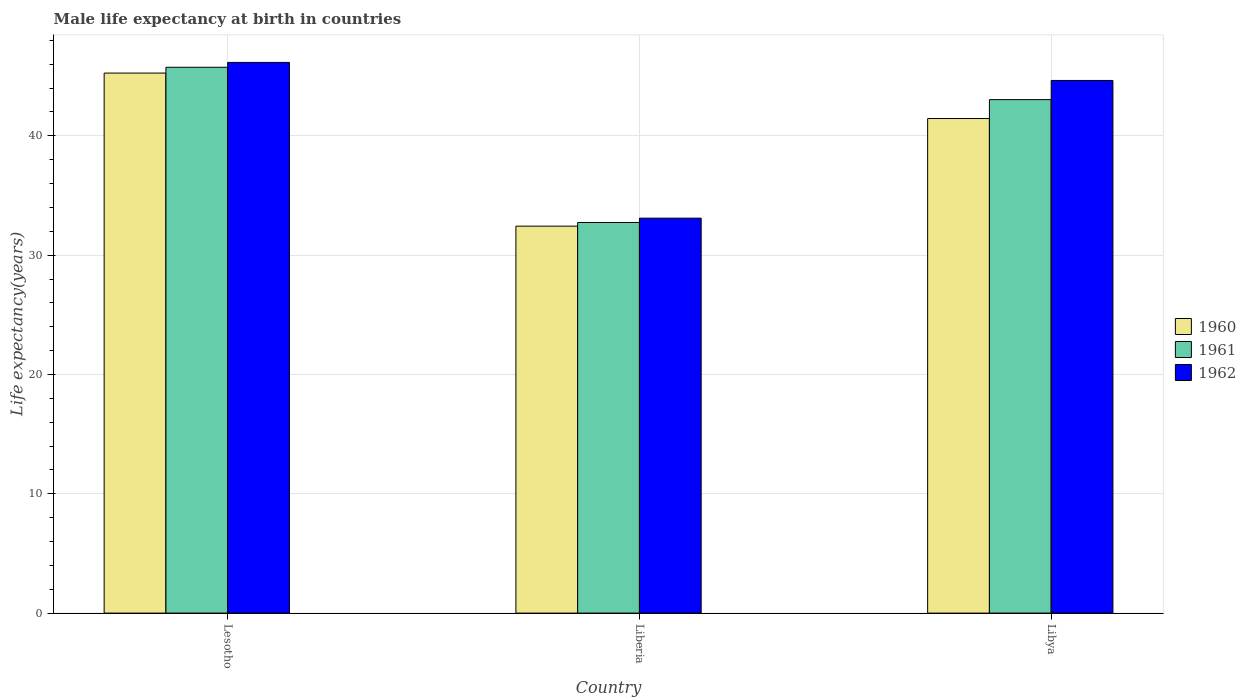How many groups of bars are there?
Your response must be concise. 3. Are the number of bars per tick equal to the number of legend labels?
Make the answer very short. Yes. How many bars are there on the 3rd tick from the left?
Your answer should be very brief. 3. How many bars are there on the 3rd tick from the right?
Your answer should be compact. 3. What is the label of the 3rd group of bars from the left?
Your response must be concise. Libya. In how many cases, is the number of bars for a given country not equal to the number of legend labels?
Make the answer very short. 0. What is the male life expectancy at birth in 1962 in Liberia?
Ensure brevity in your answer.  33.1. Across all countries, what is the maximum male life expectancy at birth in 1961?
Offer a very short reply. 45.74. Across all countries, what is the minimum male life expectancy at birth in 1962?
Your response must be concise. 33.1. In which country was the male life expectancy at birth in 1961 maximum?
Provide a short and direct response. Lesotho. In which country was the male life expectancy at birth in 1960 minimum?
Provide a succinct answer. Liberia. What is the total male life expectancy at birth in 1960 in the graph?
Make the answer very short. 119.14. What is the difference between the male life expectancy at birth in 1962 in Lesotho and that in Libya?
Offer a terse response. 1.51. What is the difference between the male life expectancy at birth in 1960 in Libya and the male life expectancy at birth in 1962 in Lesotho?
Your answer should be compact. -4.7. What is the average male life expectancy at birth in 1961 per country?
Make the answer very short. 40.5. What is the difference between the male life expectancy at birth of/in 1961 and male life expectancy at birth of/in 1960 in Lesotho?
Your answer should be compact. 0.49. In how many countries, is the male life expectancy at birth in 1960 greater than 34 years?
Give a very brief answer. 2. What is the ratio of the male life expectancy at birth in 1961 in Liberia to that in Libya?
Make the answer very short. 0.76. What is the difference between the highest and the second highest male life expectancy at birth in 1962?
Make the answer very short. -11.54. What is the difference between the highest and the lowest male life expectancy at birth in 1962?
Offer a terse response. 13.05. In how many countries, is the male life expectancy at birth in 1961 greater than the average male life expectancy at birth in 1961 taken over all countries?
Ensure brevity in your answer.  2. What does the 1st bar from the right in Lesotho represents?
Your response must be concise. 1962. Is it the case that in every country, the sum of the male life expectancy at birth in 1961 and male life expectancy at birth in 1960 is greater than the male life expectancy at birth in 1962?
Provide a short and direct response. Yes. Are all the bars in the graph horizontal?
Offer a very short reply. No. How many countries are there in the graph?
Make the answer very short. 3. Does the graph contain any zero values?
Your answer should be very brief. No. Where does the legend appear in the graph?
Make the answer very short. Center right. What is the title of the graph?
Give a very brief answer. Male life expectancy at birth in countries. What is the label or title of the X-axis?
Give a very brief answer. Country. What is the label or title of the Y-axis?
Give a very brief answer. Life expectancy(years). What is the Life expectancy(years) of 1960 in Lesotho?
Ensure brevity in your answer.  45.26. What is the Life expectancy(years) in 1961 in Lesotho?
Provide a short and direct response. 45.74. What is the Life expectancy(years) in 1962 in Lesotho?
Keep it short and to the point. 46.15. What is the Life expectancy(years) in 1960 in Liberia?
Provide a succinct answer. 32.43. What is the Life expectancy(years) in 1961 in Liberia?
Make the answer very short. 32.74. What is the Life expectancy(years) in 1962 in Liberia?
Your answer should be very brief. 33.1. What is the Life expectancy(years) of 1960 in Libya?
Ensure brevity in your answer.  41.45. What is the Life expectancy(years) in 1961 in Libya?
Offer a very short reply. 43.03. What is the Life expectancy(years) of 1962 in Libya?
Your response must be concise. 44.64. Across all countries, what is the maximum Life expectancy(years) in 1960?
Provide a succinct answer. 45.26. Across all countries, what is the maximum Life expectancy(years) of 1961?
Offer a terse response. 45.74. Across all countries, what is the maximum Life expectancy(years) of 1962?
Make the answer very short. 46.15. Across all countries, what is the minimum Life expectancy(years) in 1960?
Ensure brevity in your answer.  32.43. Across all countries, what is the minimum Life expectancy(years) of 1961?
Keep it short and to the point. 32.74. Across all countries, what is the minimum Life expectancy(years) in 1962?
Your answer should be compact. 33.1. What is the total Life expectancy(years) of 1960 in the graph?
Your answer should be very brief. 119.14. What is the total Life expectancy(years) of 1961 in the graph?
Your answer should be compact. 121.52. What is the total Life expectancy(years) in 1962 in the graph?
Make the answer very short. 123.89. What is the difference between the Life expectancy(years) of 1960 in Lesotho and that in Liberia?
Your answer should be compact. 12.83. What is the difference between the Life expectancy(years) of 1961 in Lesotho and that in Liberia?
Offer a terse response. 13.01. What is the difference between the Life expectancy(years) of 1962 in Lesotho and that in Liberia?
Offer a terse response. 13.05. What is the difference between the Life expectancy(years) in 1960 in Lesotho and that in Libya?
Your response must be concise. 3.81. What is the difference between the Life expectancy(years) of 1961 in Lesotho and that in Libya?
Your answer should be very brief. 2.71. What is the difference between the Life expectancy(years) of 1962 in Lesotho and that in Libya?
Ensure brevity in your answer.  1.51. What is the difference between the Life expectancy(years) of 1960 in Liberia and that in Libya?
Offer a very short reply. -9.02. What is the difference between the Life expectancy(years) in 1961 in Liberia and that in Libya?
Ensure brevity in your answer.  -10.3. What is the difference between the Life expectancy(years) of 1962 in Liberia and that in Libya?
Provide a succinct answer. -11.54. What is the difference between the Life expectancy(years) in 1960 in Lesotho and the Life expectancy(years) in 1961 in Liberia?
Give a very brief answer. 12.52. What is the difference between the Life expectancy(years) in 1960 in Lesotho and the Life expectancy(years) in 1962 in Liberia?
Your answer should be very brief. 12.16. What is the difference between the Life expectancy(years) of 1961 in Lesotho and the Life expectancy(years) of 1962 in Liberia?
Offer a very short reply. 12.64. What is the difference between the Life expectancy(years) in 1960 in Lesotho and the Life expectancy(years) in 1961 in Libya?
Your answer should be compact. 2.23. What is the difference between the Life expectancy(years) in 1960 in Lesotho and the Life expectancy(years) in 1962 in Libya?
Provide a succinct answer. 0.62. What is the difference between the Life expectancy(years) of 1961 in Lesotho and the Life expectancy(years) of 1962 in Libya?
Your answer should be compact. 1.1. What is the difference between the Life expectancy(years) in 1960 in Liberia and the Life expectancy(years) in 1961 in Libya?
Keep it short and to the point. -10.6. What is the difference between the Life expectancy(years) in 1960 in Liberia and the Life expectancy(years) in 1962 in Libya?
Ensure brevity in your answer.  -12.21. What is the difference between the Life expectancy(years) of 1961 in Liberia and the Life expectancy(years) of 1962 in Libya?
Your response must be concise. -11.9. What is the average Life expectancy(years) of 1960 per country?
Give a very brief answer. 39.71. What is the average Life expectancy(years) of 1961 per country?
Provide a short and direct response. 40.51. What is the average Life expectancy(years) of 1962 per country?
Make the answer very short. 41.3. What is the difference between the Life expectancy(years) of 1960 and Life expectancy(years) of 1961 in Lesotho?
Offer a very short reply. -0.48. What is the difference between the Life expectancy(years) in 1960 and Life expectancy(years) in 1962 in Lesotho?
Make the answer very short. -0.89. What is the difference between the Life expectancy(years) in 1961 and Life expectancy(years) in 1962 in Lesotho?
Provide a succinct answer. -0.41. What is the difference between the Life expectancy(years) in 1960 and Life expectancy(years) in 1961 in Liberia?
Your response must be concise. -0.31. What is the difference between the Life expectancy(years) of 1960 and Life expectancy(years) of 1962 in Liberia?
Provide a succinct answer. -0.67. What is the difference between the Life expectancy(years) of 1961 and Life expectancy(years) of 1962 in Liberia?
Your answer should be very brief. -0.36. What is the difference between the Life expectancy(years) in 1960 and Life expectancy(years) in 1961 in Libya?
Offer a terse response. -1.58. What is the difference between the Life expectancy(years) in 1960 and Life expectancy(years) in 1962 in Libya?
Your answer should be very brief. -3.19. What is the difference between the Life expectancy(years) in 1961 and Life expectancy(years) in 1962 in Libya?
Provide a succinct answer. -1.6. What is the ratio of the Life expectancy(years) in 1960 in Lesotho to that in Liberia?
Your response must be concise. 1.4. What is the ratio of the Life expectancy(years) of 1961 in Lesotho to that in Liberia?
Your answer should be very brief. 1.4. What is the ratio of the Life expectancy(years) of 1962 in Lesotho to that in Liberia?
Offer a very short reply. 1.39. What is the ratio of the Life expectancy(years) in 1960 in Lesotho to that in Libya?
Your answer should be very brief. 1.09. What is the ratio of the Life expectancy(years) of 1961 in Lesotho to that in Libya?
Give a very brief answer. 1.06. What is the ratio of the Life expectancy(years) of 1962 in Lesotho to that in Libya?
Ensure brevity in your answer.  1.03. What is the ratio of the Life expectancy(years) in 1960 in Liberia to that in Libya?
Provide a short and direct response. 0.78. What is the ratio of the Life expectancy(years) in 1961 in Liberia to that in Libya?
Give a very brief answer. 0.76. What is the ratio of the Life expectancy(years) of 1962 in Liberia to that in Libya?
Give a very brief answer. 0.74. What is the difference between the highest and the second highest Life expectancy(years) of 1960?
Provide a short and direct response. 3.81. What is the difference between the highest and the second highest Life expectancy(years) in 1961?
Offer a very short reply. 2.71. What is the difference between the highest and the second highest Life expectancy(years) in 1962?
Your answer should be compact. 1.51. What is the difference between the highest and the lowest Life expectancy(years) of 1960?
Offer a terse response. 12.83. What is the difference between the highest and the lowest Life expectancy(years) in 1961?
Your answer should be very brief. 13.01. What is the difference between the highest and the lowest Life expectancy(years) of 1962?
Provide a short and direct response. 13.05. 